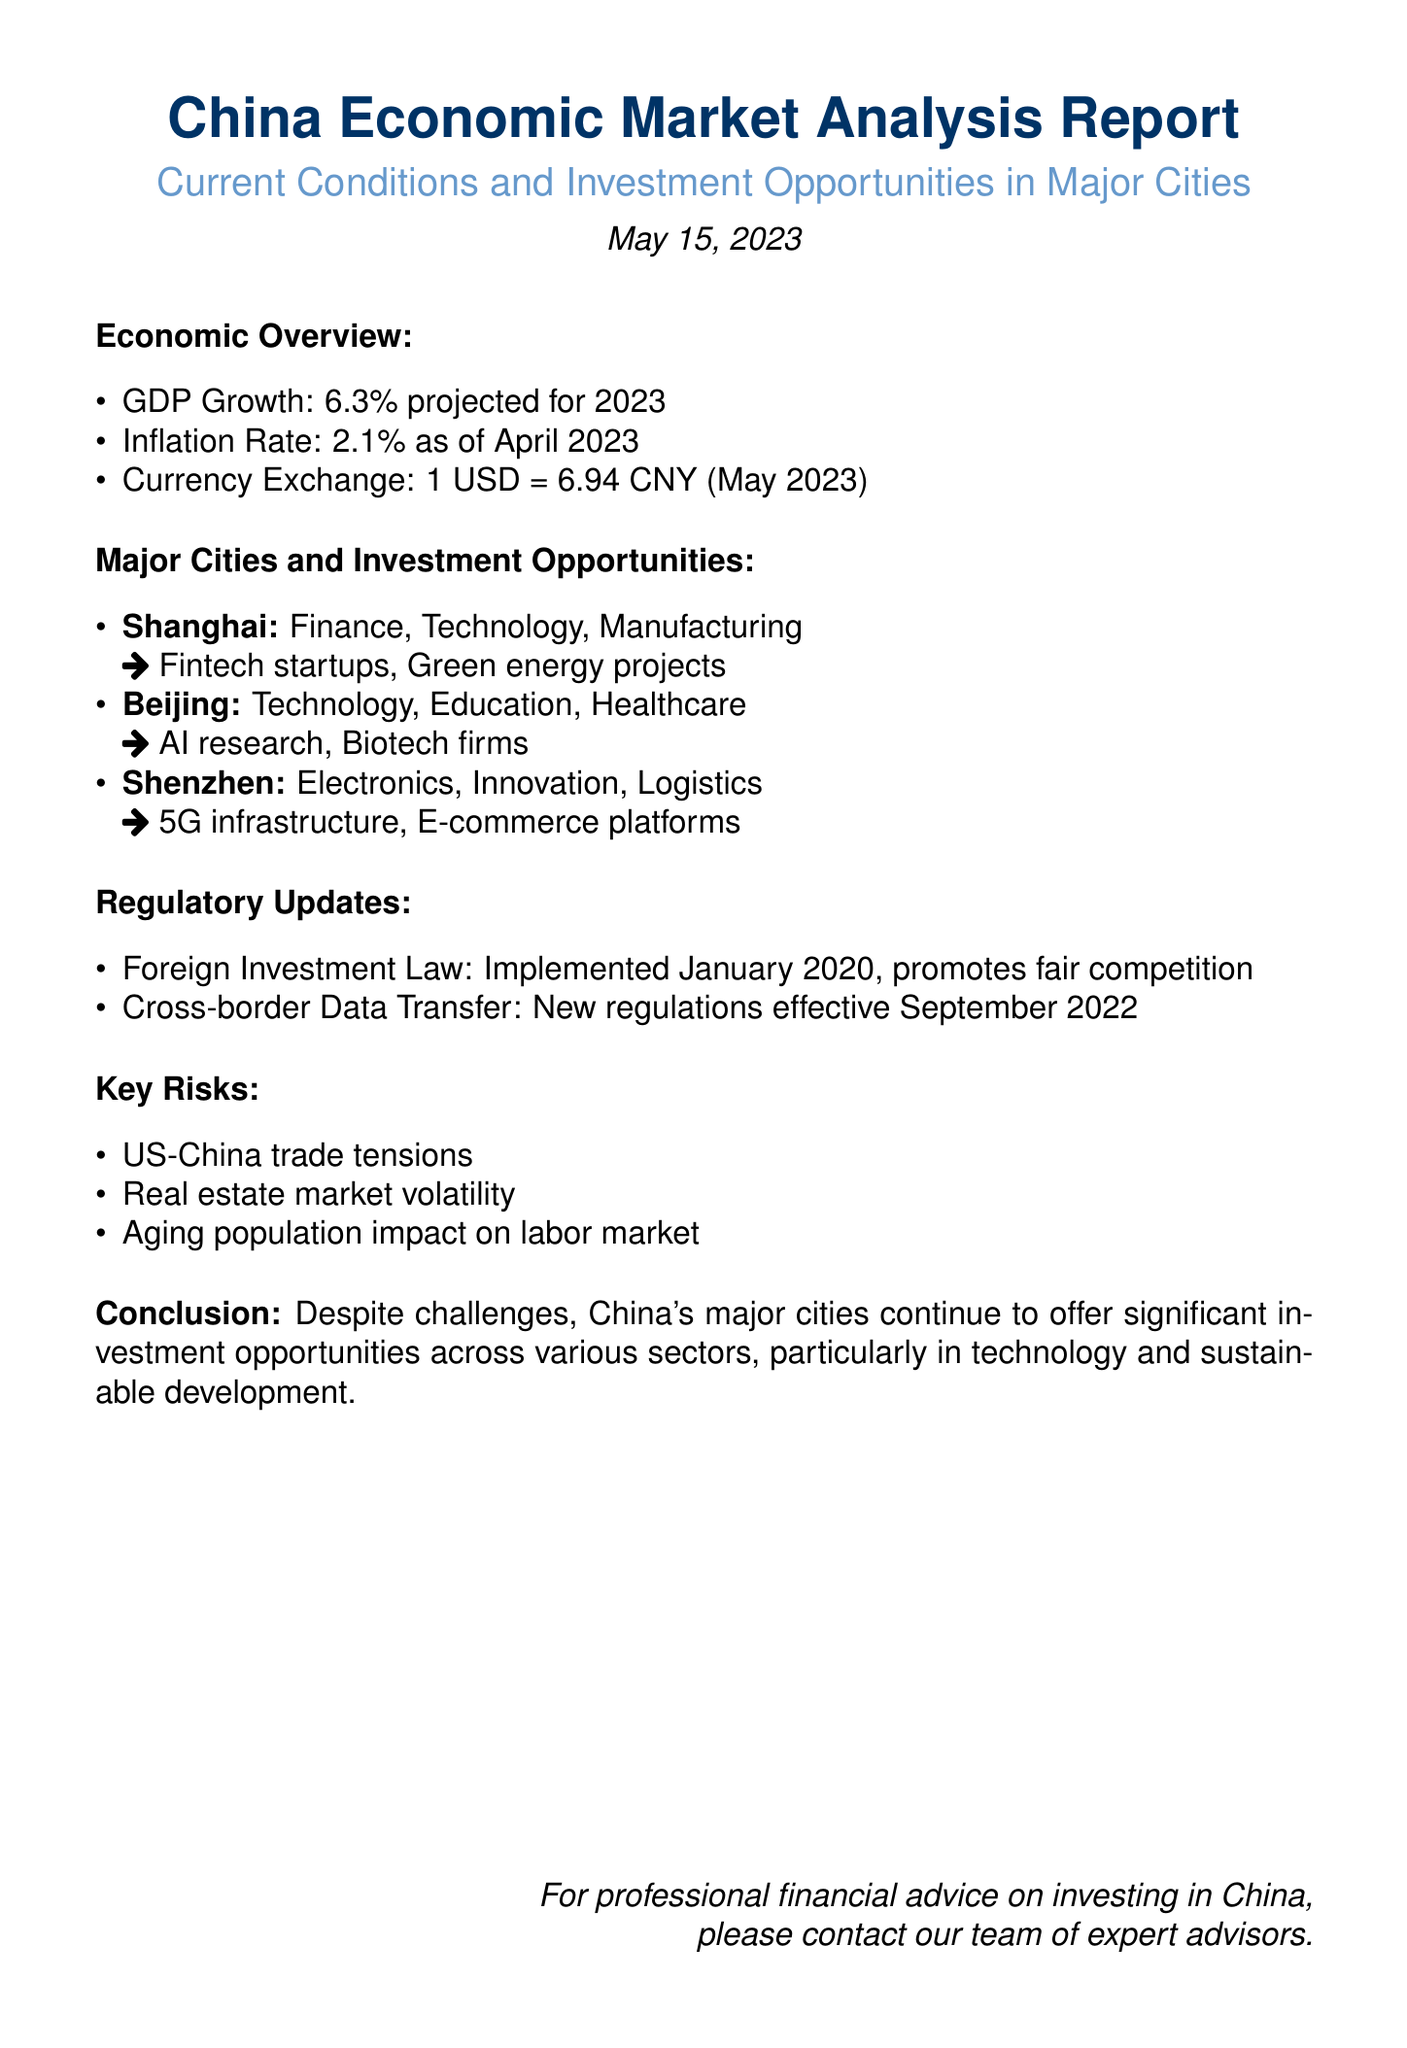What is the projected GDP growth for 2023? The GDP growth is projected as mentioned in the Economic Overview section of the document.
Answer: 6.3% What is the inflation rate as of April 2023? The inflation rate is specifically indicated in the Economic Overview section of the document.
Answer: 2.1% What is the currency exchange rate for USD to CNY? The exchange rate is detailed in the Economic Overview section of the document.
Answer: 1 USD = 6.94 CNY Which city is known for finance and technology investment opportunities? The Major Cities and Investment Opportunities section names this city explicitly.
Answer: Shanghai What are the key risks mentioned in the document? The key risks are listed in their respective section, requiring identification of multiple items.
Answer: US-China trade tensions, Real estate market volatility, Aging population impact on labor market When was the Foreign Investment Law implemented? The document states the implementation date, which is relevant to the Regulatory Updates section.
Answer: January 2020 What types of projects are highlighted for Shenzhen? The document outlines specific sectors and examples for Shenzhen, leading to this answer.
Answer: 5G infrastructure, E-commerce platforms What is the conclusion of the report? The conclusion summarizes the overall findings of the report in a concise manner.
Answer: Significant investment opportunities across various sectors What is the date of the report? The date is presented at the beginning of the document, indicating its relevance.
Answer: May 15, 2023 